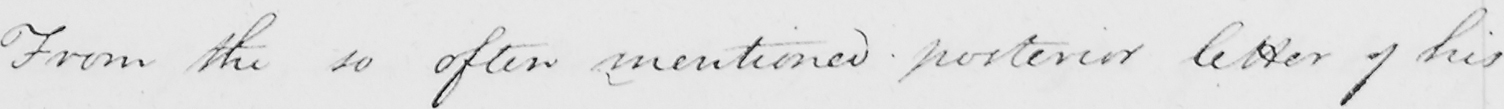Please transcribe the handwritten text in this image. From the so often mentioned posterior letter of his 